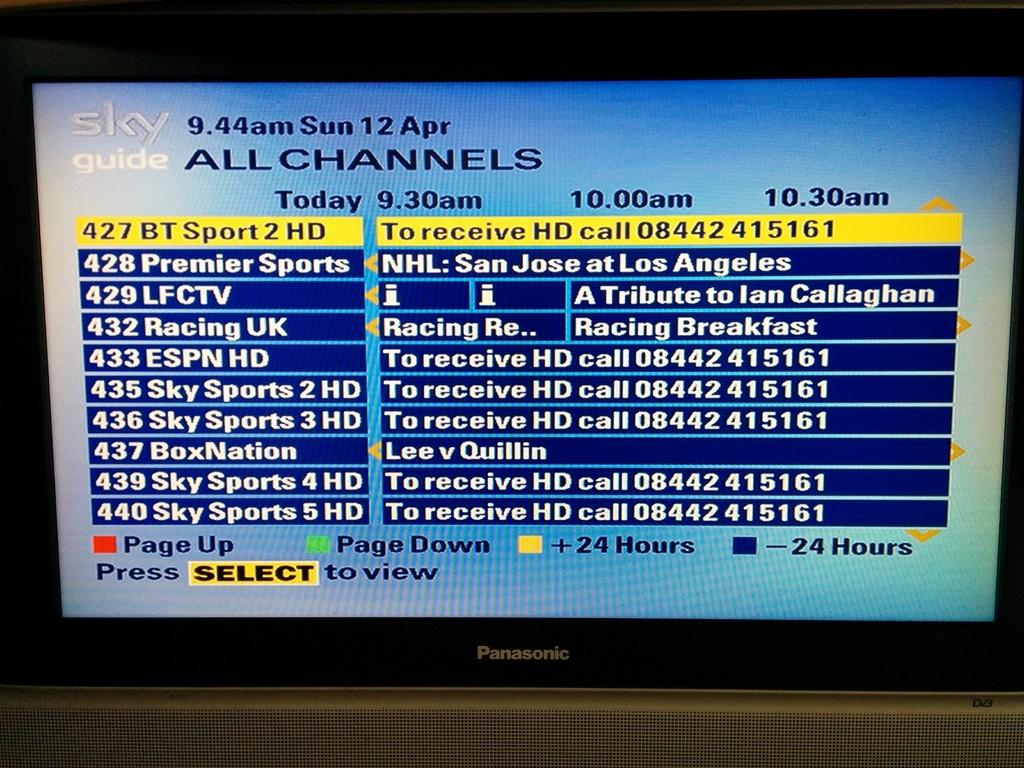Provide a one-sentence caption for the provided image. A Sky Guide display lists Sky Sports and ESPN options. 